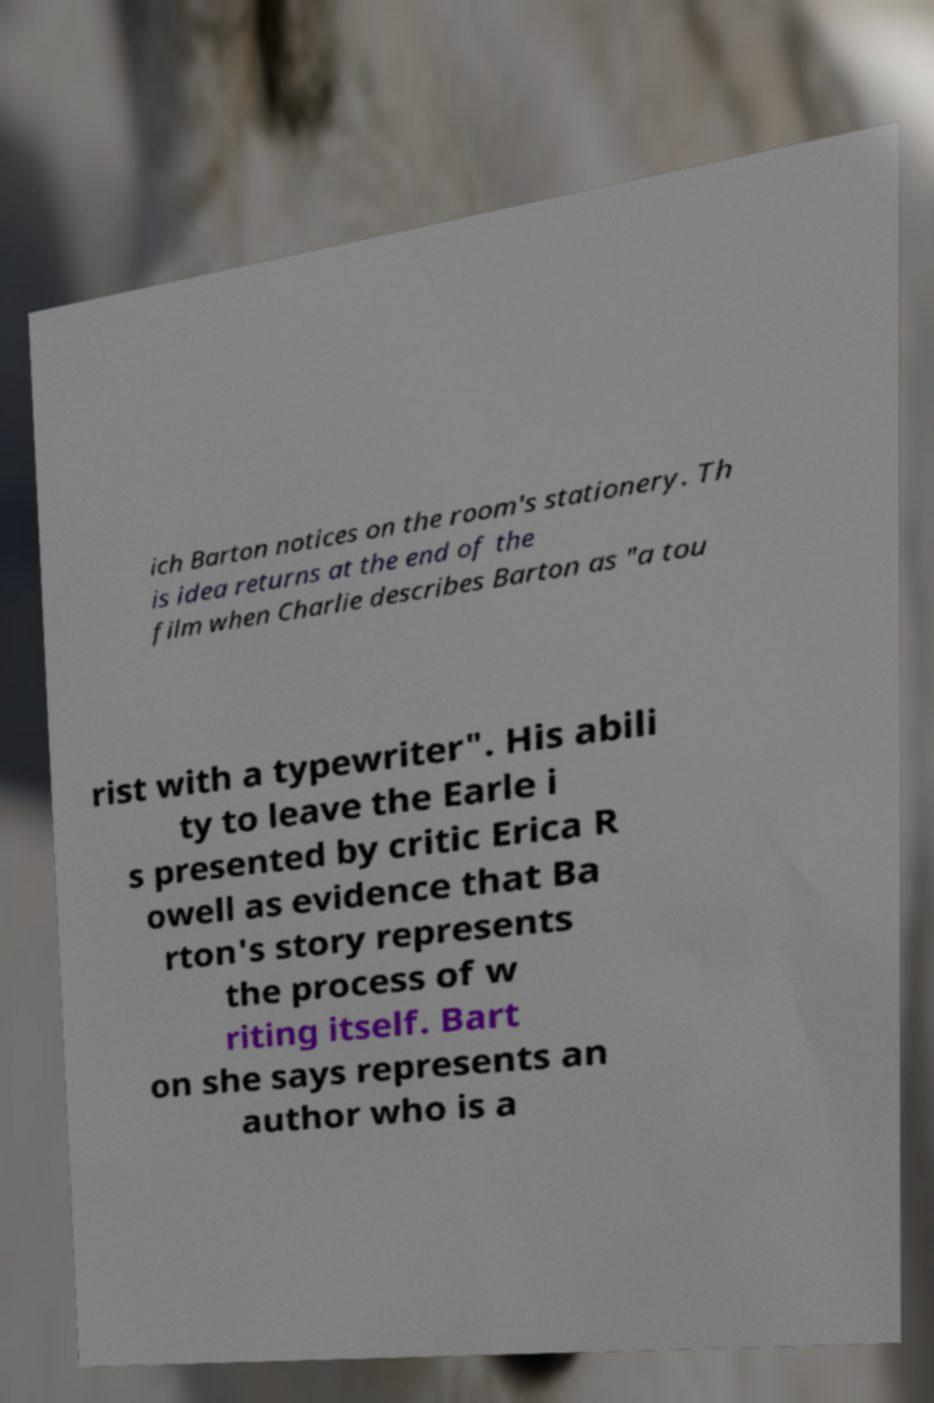Could you assist in decoding the text presented in this image and type it out clearly? ich Barton notices on the room's stationery. Th is idea returns at the end of the film when Charlie describes Barton as "a tou rist with a typewriter". His abili ty to leave the Earle i s presented by critic Erica R owell as evidence that Ba rton's story represents the process of w riting itself. Bart on she says represents an author who is a 